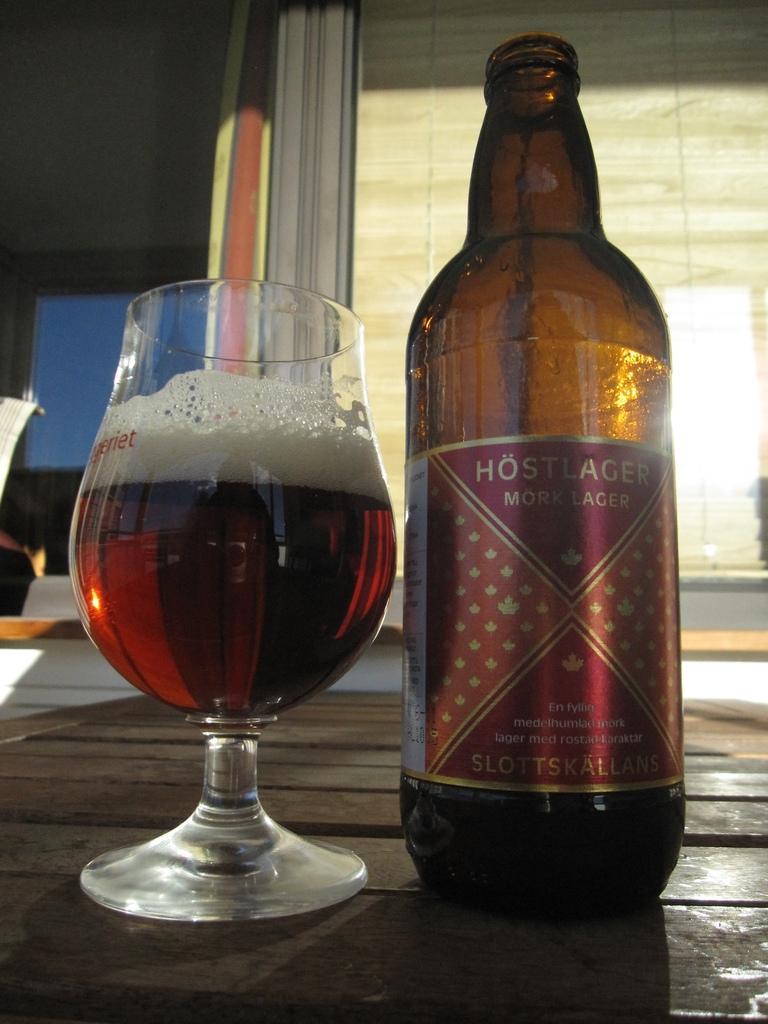Describe this image in one or two sentences. There is a wine bottle and a glass with wine on the table. In the background we can see window. 